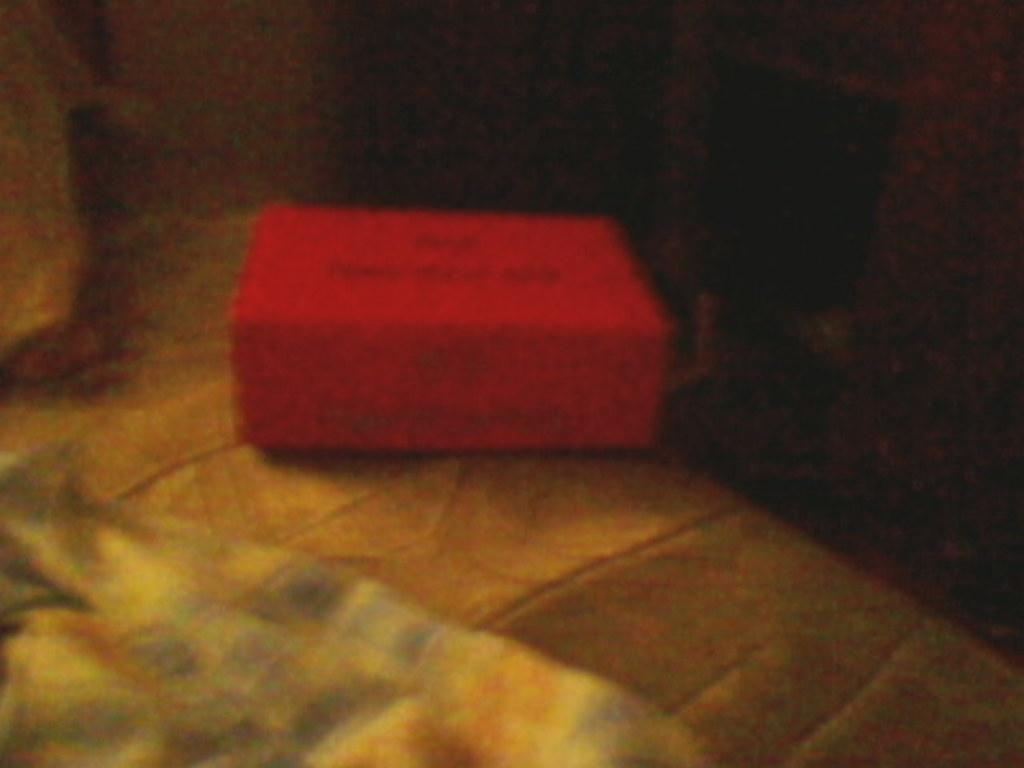What is the color of the box in the image? The box in the image is red. Where is the red box located? The red box is placed on a table. What color is the background of the image? The background of the image is black. What type of education does the lawyer in the image have? There is no lawyer or any reference to education in the image; it only features a red box on a table with a black background. 